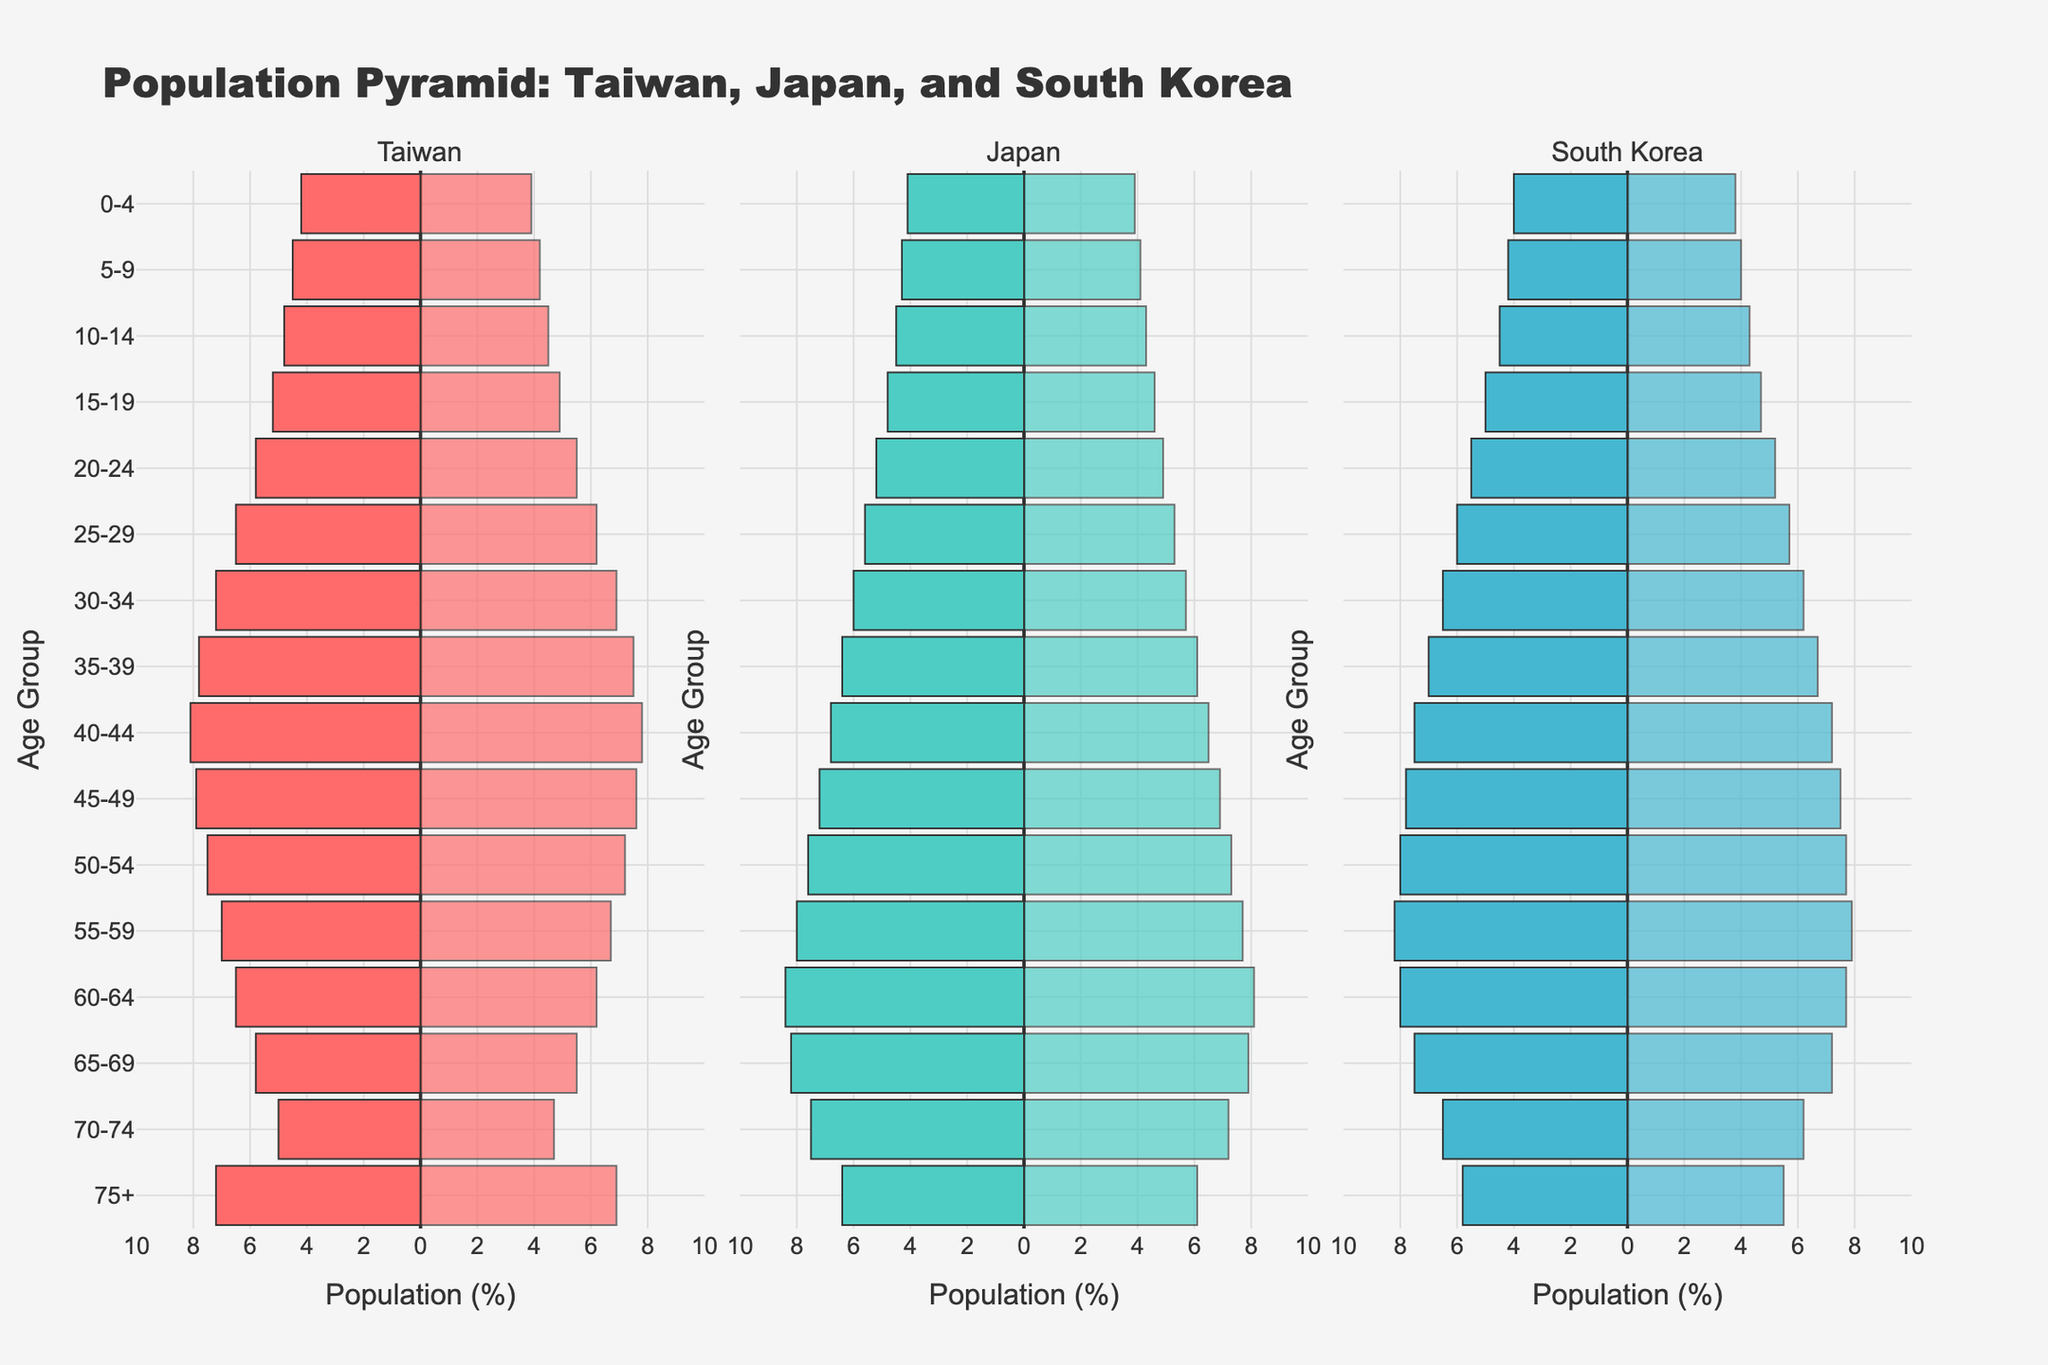What are the age groups shown in the population pyramid? The population pyramid includes age groups as marked on the y-axis, listed from top to bottom in the figure: 75+, 70-74, 65-69, 60-64, 55-59, 50-54, 45-49, 40-44, 35-39, 30-34, 25-29, 20-24, 15-19, 10-14, 5-9, and 0-4.
Answer: 75+, 70-74, 65-69, 60-64, 55-59, 50-54, 45-49, 40-44, 35-39, 30-34, 25-29, 20-24, 15-19, 10-14, 5-9, 0-4 What is the title of the population pyramid? The title is located at the top of the figure and reads "Population Pyramid: Taiwan, Japan, and South Korea".
Answer: Population Pyramid: Taiwan, Japan, and South Korea Which country has the highest male population in the 30-34 age group? By comparing the lengths of the bars for males aged 30-34, Taiwan has the longest bar at 7.2%, followed by South Korea and Japan.
Answer: Taiwan How does the female population in the 60-64 age group compare between Japan and Taiwan? The female population in Japan for the 60-64 age group is at 8.1% while in Taiwan it is 6.2%. Japan has a higher percentage.
Answer: Japan Which age group in South Korea has a higher population of females compared to males? By comparing the lengths of bars for females and males in different age groups in South Korea, the age group 55-59 indicates a higher percentage of females (7.9%) compared to males (7.7%).
Answer: 55-59 What is the age group with the highest female population percentage in Japan? Looking at the longest bar for females in Japan, the age group 60-64 has the highest percentage at 8.1%.
Answer: 60-64 If you sum the percentage of the population for males and females aged 0-4 in Taiwan, what is the total? The male population percentage is 4.2% and the female population percentage is 3.9%. Summing these gives 4.2 + 3.9 = 8.1%.
Answer: 8.1% Which country has the smallest population percentage for males aged 75+? By comparing the lengths of the bars for males aged 75+, South Korea has the smallest bar at 5.8%.
Answer: South Korea For which age group do all three countries have almost the same male population percentage? The age group 0-4 has similar male population percentages across Taiwan (4.2%), Japan (4.1%), and South Korea (4.0%).
Answer: 0-4 Which gender has a consistently higher population percentage in the age groups 25-29 and 30-34 in South Korea? In South Korea, comparing bars for males and females in the age groups 25-29 and 30-34, males have higher percentages at 6.0% and 6.5% respectively.
Answer: Male 